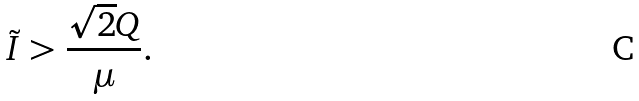Convert formula to latex. <formula><loc_0><loc_0><loc_500><loc_500>\tilde { I } > \frac { \sqrt { 2 } Q } { \mu } .</formula> 